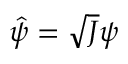Convert formula to latex. <formula><loc_0><loc_0><loc_500><loc_500>\hat { \psi } = \sqrt { J } \psi</formula> 